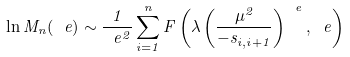Convert formula to latex. <formula><loc_0><loc_0><loc_500><loc_500>\ln M _ { n } ( \ e ) \sim \frac { 1 } { \ e ^ { 2 } } \sum _ { i = 1 } ^ { n } F \left ( \lambda \left ( \frac { \mu ^ { 2 } } { - s _ { i , i + 1 } } \right ) ^ { \ e } , \ e \right )</formula> 